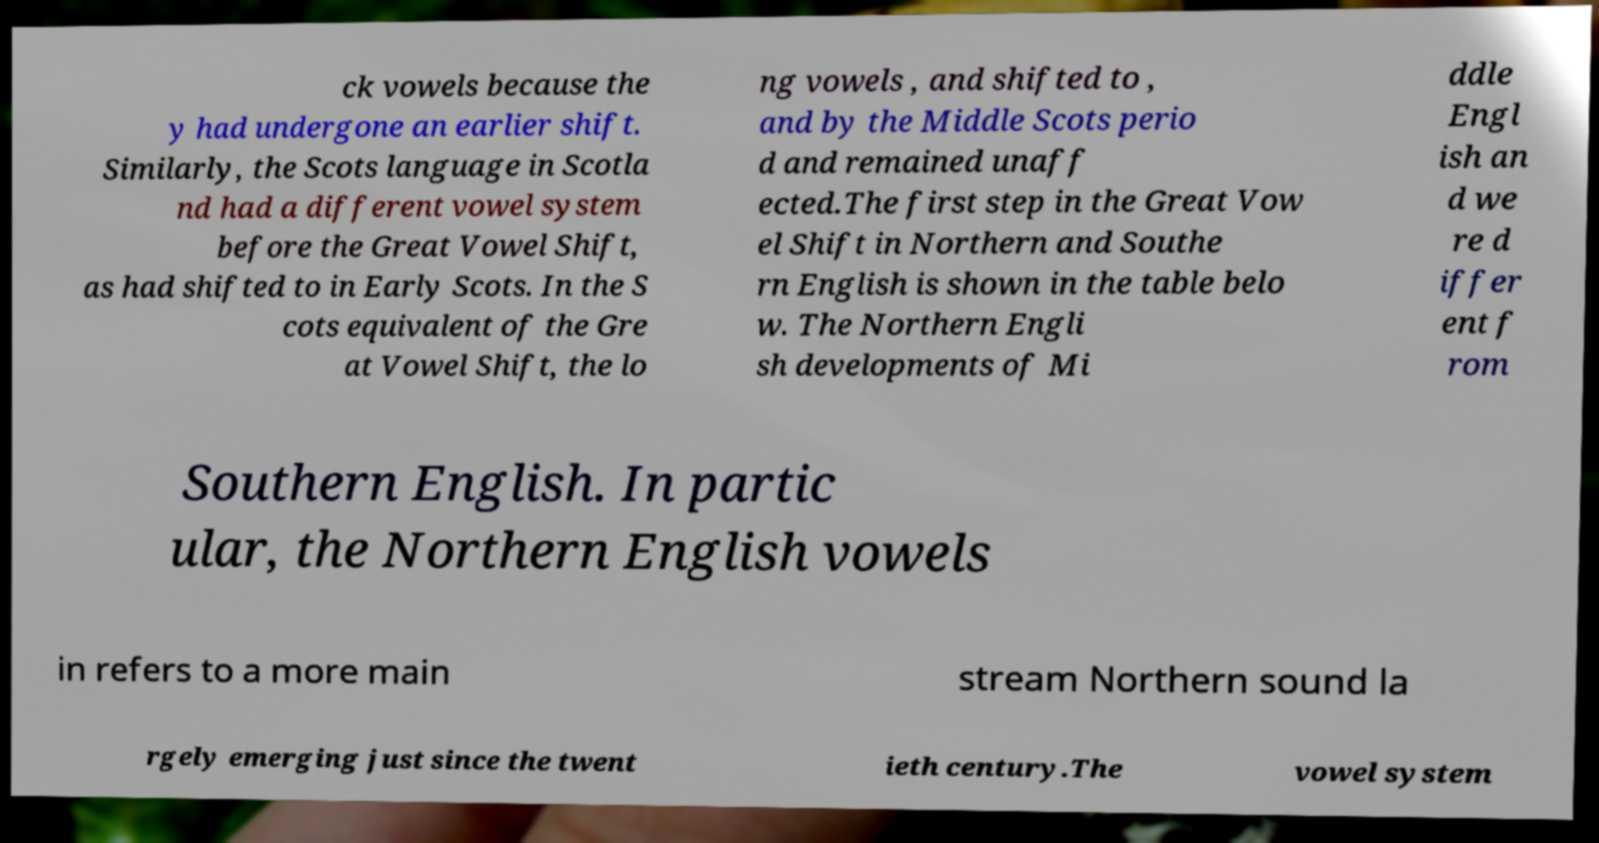For documentation purposes, I need the text within this image transcribed. Could you provide that? ck vowels because the y had undergone an earlier shift. Similarly, the Scots language in Scotla nd had a different vowel system before the Great Vowel Shift, as had shifted to in Early Scots. In the S cots equivalent of the Gre at Vowel Shift, the lo ng vowels , and shifted to , and by the Middle Scots perio d and remained unaff ected.The first step in the Great Vow el Shift in Northern and Southe rn English is shown in the table belo w. The Northern Engli sh developments of Mi ddle Engl ish an d we re d iffer ent f rom Southern English. In partic ular, the Northern English vowels in refers to a more main stream Northern sound la rgely emerging just since the twent ieth century.The vowel system 